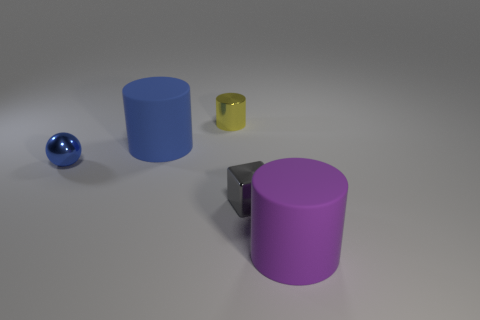Add 4 red metallic cylinders. How many objects exist? 9 Subtract all cylinders. How many objects are left? 2 Subtract all small yellow cylinders. Subtract all metallic cylinders. How many objects are left? 3 Add 5 small gray things. How many small gray things are left? 6 Add 2 big blue rubber cylinders. How many big blue rubber cylinders exist? 3 Subtract 0 gray spheres. How many objects are left? 5 